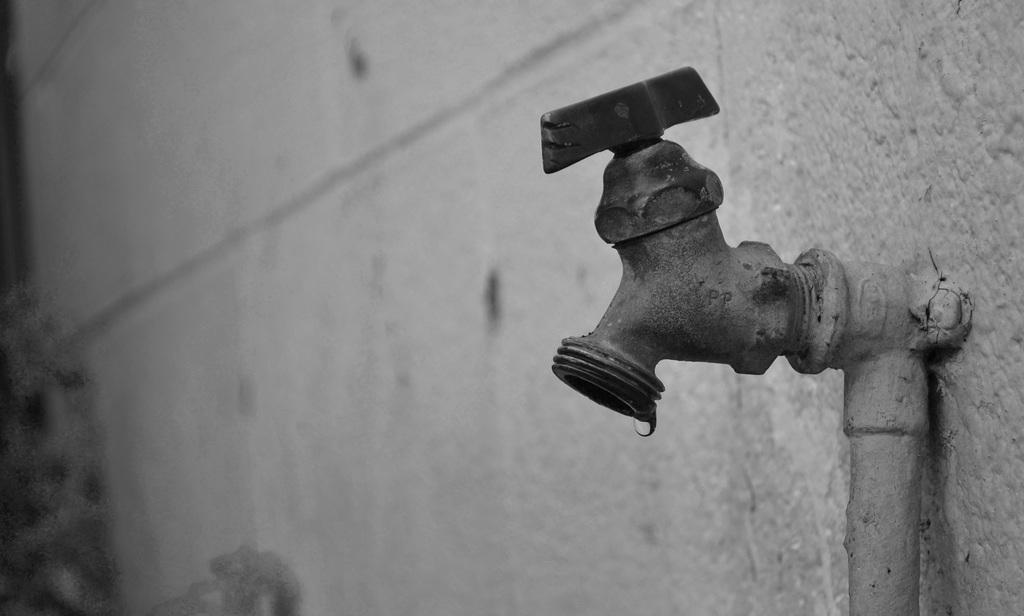What object is located on the right side of the image? There is a water tap on the right side of the image. What is the color scheme of the image? The image is black and white in color. What type of store can be seen in the image? There is no store present in the image; it features a water tap. What is the authority rating of the water tap in the image? There is no authority rating associated with the water tap in the image, as it is an inanimate object. 